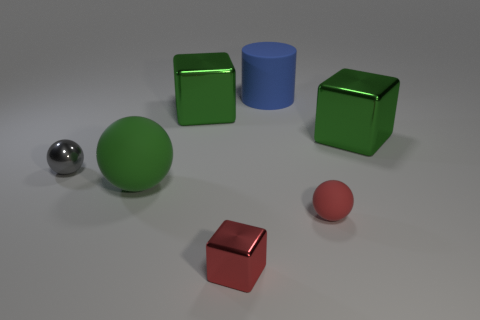There is a green cube on the left side of the red cube; is it the same size as the small red metallic cube?
Your answer should be very brief. No. Is the number of large shiny cubes less than the number of small red metal objects?
Keep it short and to the point. No. There is a object that is the same color as the tiny block; what shape is it?
Your response must be concise. Sphere. There is a gray metallic ball; how many big matte spheres are left of it?
Offer a terse response. 0. Do the big blue rubber thing and the gray metallic thing have the same shape?
Make the answer very short. No. What number of things are both in front of the matte cylinder and behind the red ball?
Keep it short and to the point. 4. How many objects are either large green things or large objects that are left of the red shiny thing?
Ensure brevity in your answer.  3. Are there more red spheres than tiny purple metallic blocks?
Offer a very short reply. Yes. What is the shape of the tiny red object that is behind the tiny metallic cube?
Ensure brevity in your answer.  Sphere. What number of small red things are the same shape as the gray thing?
Your response must be concise. 1. 